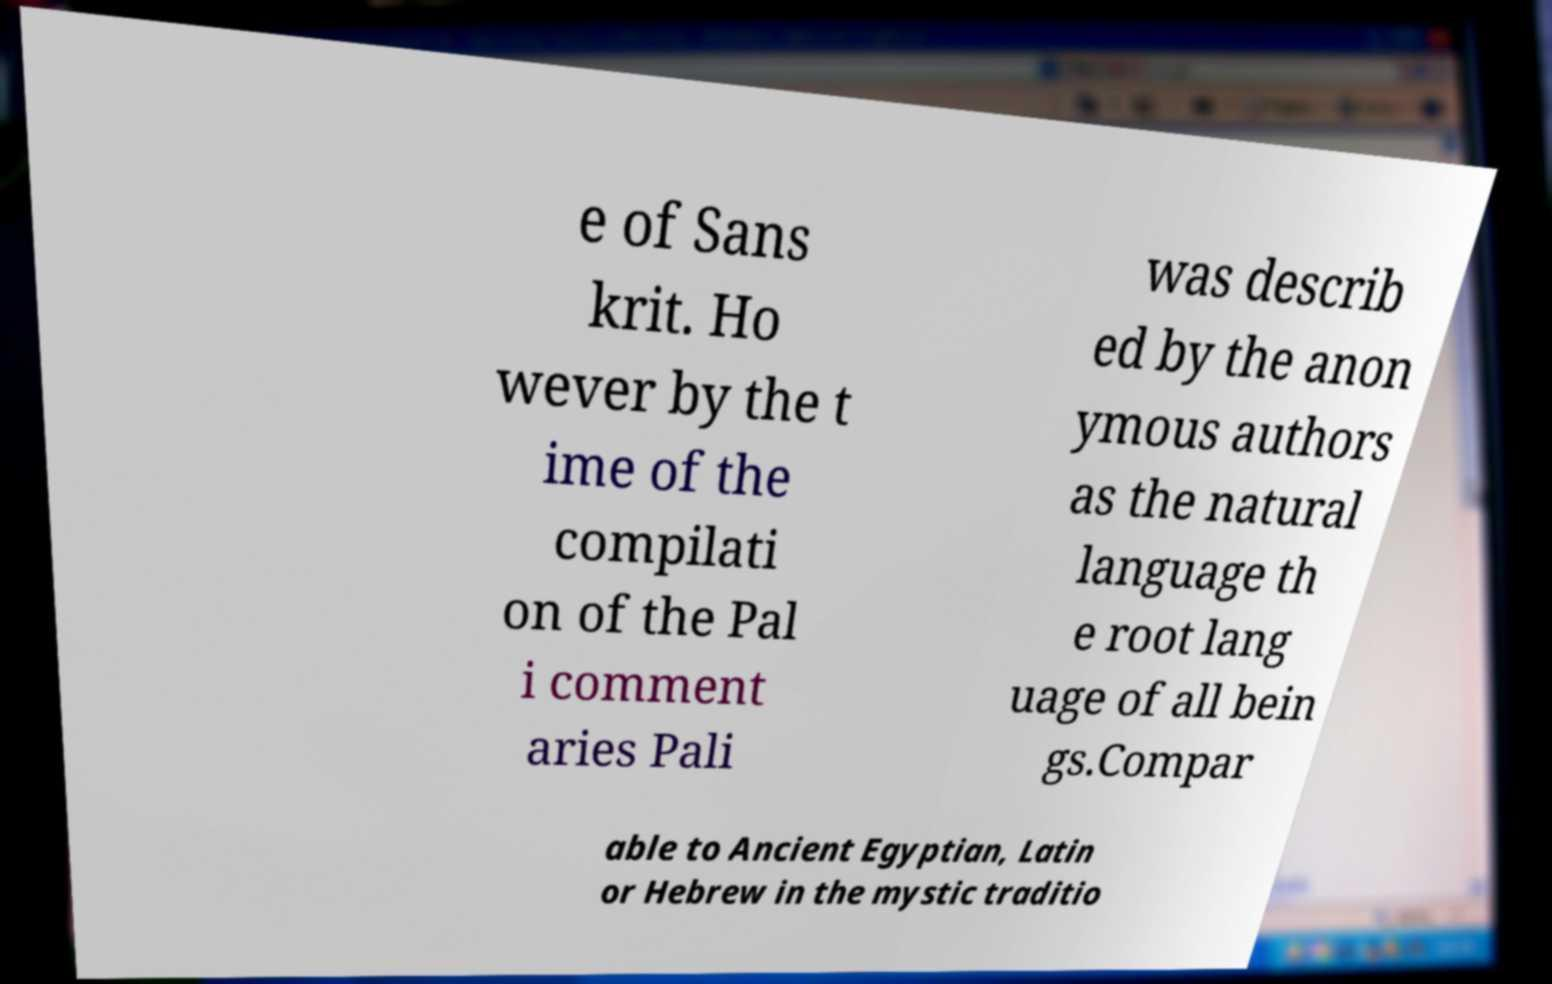Can you accurately transcribe the text from the provided image for me? e of Sans krit. Ho wever by the t ime of the compilati on of the Pal i comment aries Pali was describ ed by the anon ymous authors as the natural language th e root lang uage of all bein gs.Compar able to Ancient Egyptian, Latin or Hebrew in the mystic traditio 